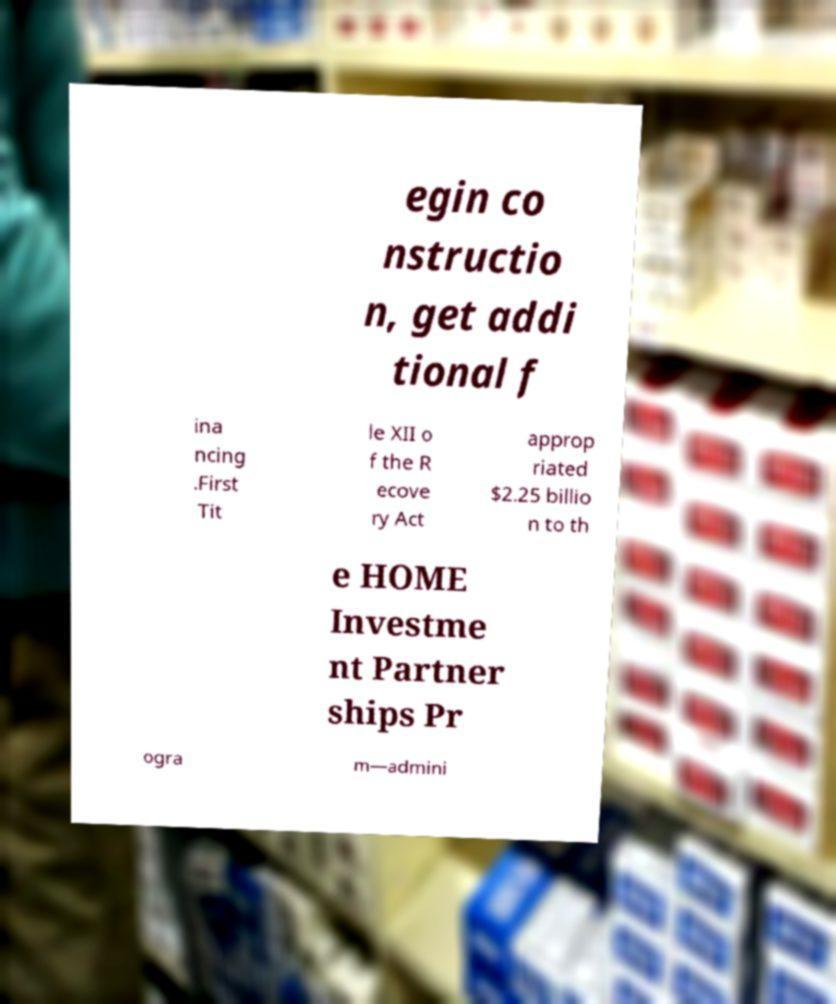Could you extract and type out the text from this image? egin co nstructio n, get addi tional f ina ncing .First Tit le XII o f the R ecove ry Act approp riated $2.25 billio n to th e HOME Investme nt Partner ships Pr ogra m—admini 